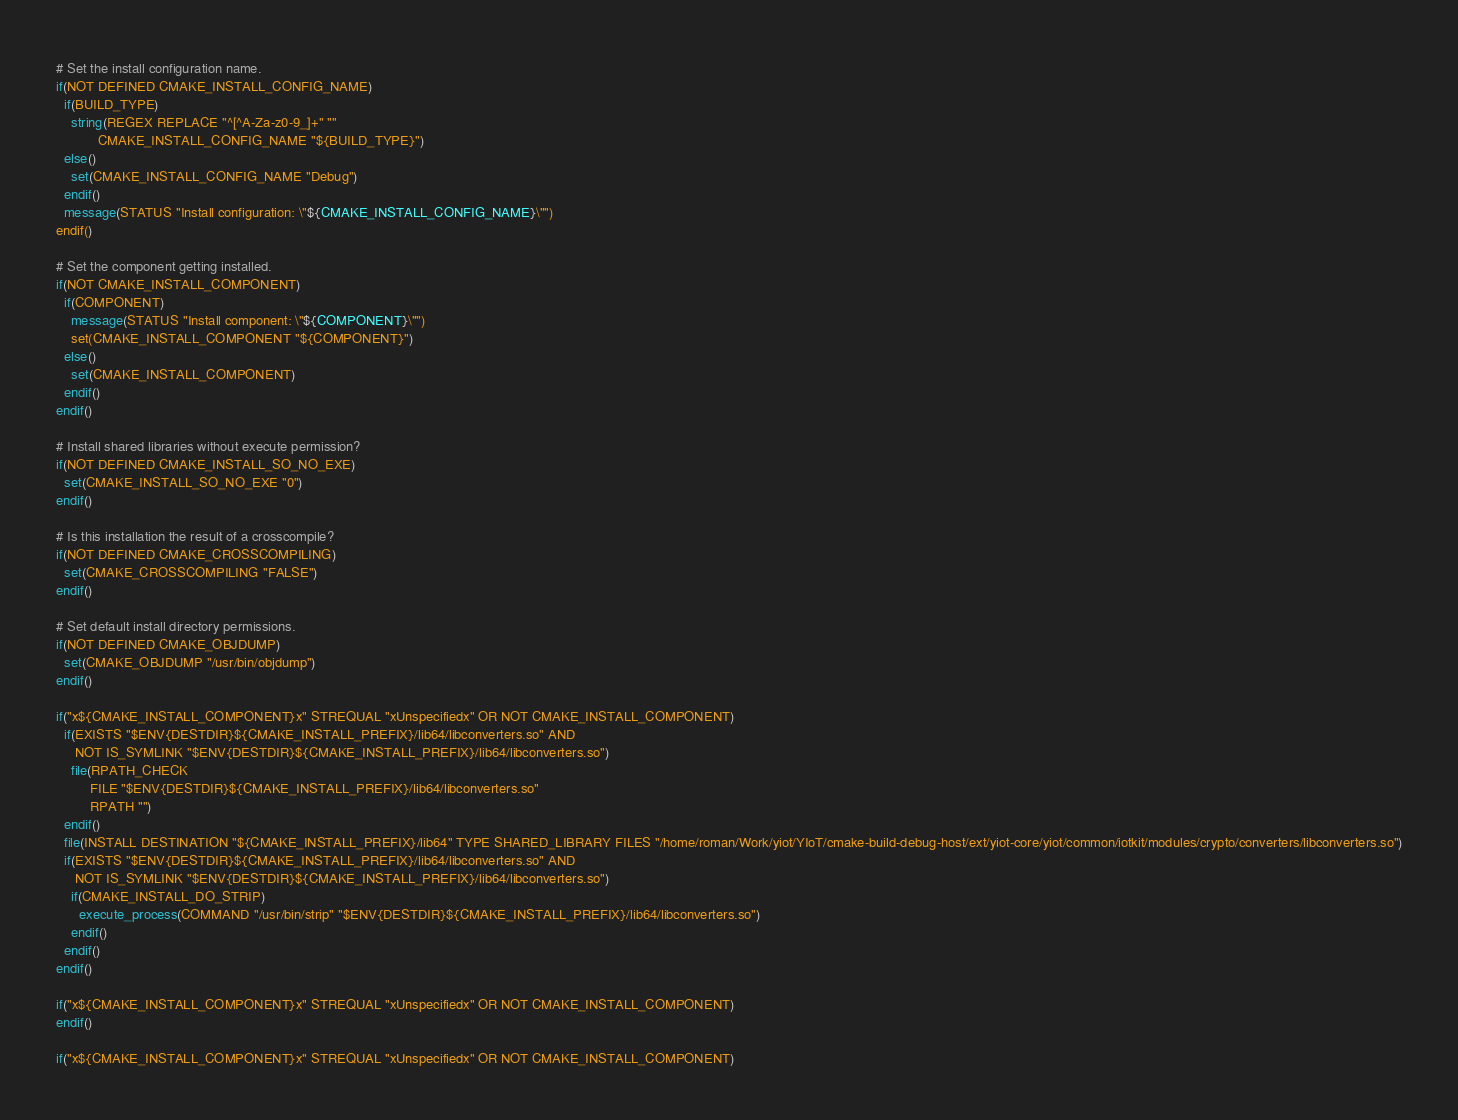<code> <loc_0><loc_0><loc_500><loc_500><_CMake_># Set the install configuration name.
if(NOT DEFINED CMAKE_INSTALL_CONFIG_NAME)
  if(BUILD_TYPE)
    string(REGEX REPLACE "^[^A-Za-z0-9_]+" ""
           CMAKE_INSTALL_CONFIG_NAME "${BUILD_TYPE}")
  else()
    set(CMAKE_INSTALL_CONFIG_NAME "Debug")
  endif()
  message(STATUS "Install configuration: \"${CMAKE_INSTALL_CONFIG_NAME}\"")
endif()

# Set the component getting installed.
if(NOT CMAKE_INSTALL_COMPONENT)
  if(COMPONENT)
    message(STATUS "Install component: \"${COMPONENT}\"")
    set(CMAKE_INSTALL_COMPONENT "${COMPONENT}")
  else()
    set(CMAKE_INSTALL_COMPONENT)
  endif()
endif()

# Install shared libraries without execute permission?
if(NOT DEFINED CMAKE_INSTALL_SO_NO_EXE)
  set(CMAKE_INSTALL_SO_NO_EXE "0")
endif()

# Is this installation the result of a crosscompile?
if(NOT DEFINED CMAKE_CROSSCOMPILING)
  set(CMAKE_CROSSCOMPILING "FALSE")
endif()

# Set default install directory permissions.
if(NOT DEFINED CMAKE_OBJDUMP)
  set(CMAKE_OBJDUMP "/usr/bin/objdump")
endif()

if("x${CMAKE_INSTALL_COMPONENT}x" STREQUAL "xUnspecifiedx" OR NOT CMAKE_INSTALL_COMPONENT)
  if(EXISTS "$ENV{DESTDIR}${CMAKE_INSTALL_PREFIX}/lib64/libconverters.so" AND
     NOT IS_SYMLINK "$ENV{DESTDIR}${CMAKE_INSTALL_PREFIX}/lib64/libconverters.so")
    file(RPATH_CHECK
         FILE "$ENV{DESTDIR}${CMAKE_INSTALL_PREFIX}/lib64/libconverters.so"
         RPATH "")
  endif()
  file(INSTALL DESTINATION "${CMAKE_INSTALL_PREFIX}/lib64" TYPE SHARED_LIBRARY FILES "/home/roman/Work/yiot/YIoT/cmake-build-debug-host/ext/yiot-core/yiot/common/iotkit/modules/crypto/converters/libconverters.so")
  if(EXISTS "$ENV{DESTDIR}${CMAKE_INSTALL_PREFIX}/lib64/libconverters.so" AND
     NOT IS_SYMLINK "$ENV{DESTDIR}${CMAKE_INSTALL_PREFIX}/lib64/libconverters.so")
    if(CMAKE_INSTALL_DO_STRIP)
      execute_process(COMMAND "/usr/bin/strip" "$ENV{DESTDIR}${CMAKE_INSTALL_PREFIX}/lib64/libconverters.so")
    endif()
  endif()
endif()

if("x${CMAKE_INSTALL_COMPONENT}x" STREQUAL "xUnspecifiedx" OR NOT CMAKE_INSTALL_COMPONENT)
endif()

if("x${CMAKE_INSTALL_COMPONENT}x" STREQUAL "xUnspecifiedx" OR NOT CMAKE_INSTALL_COMPONENT)</code> 